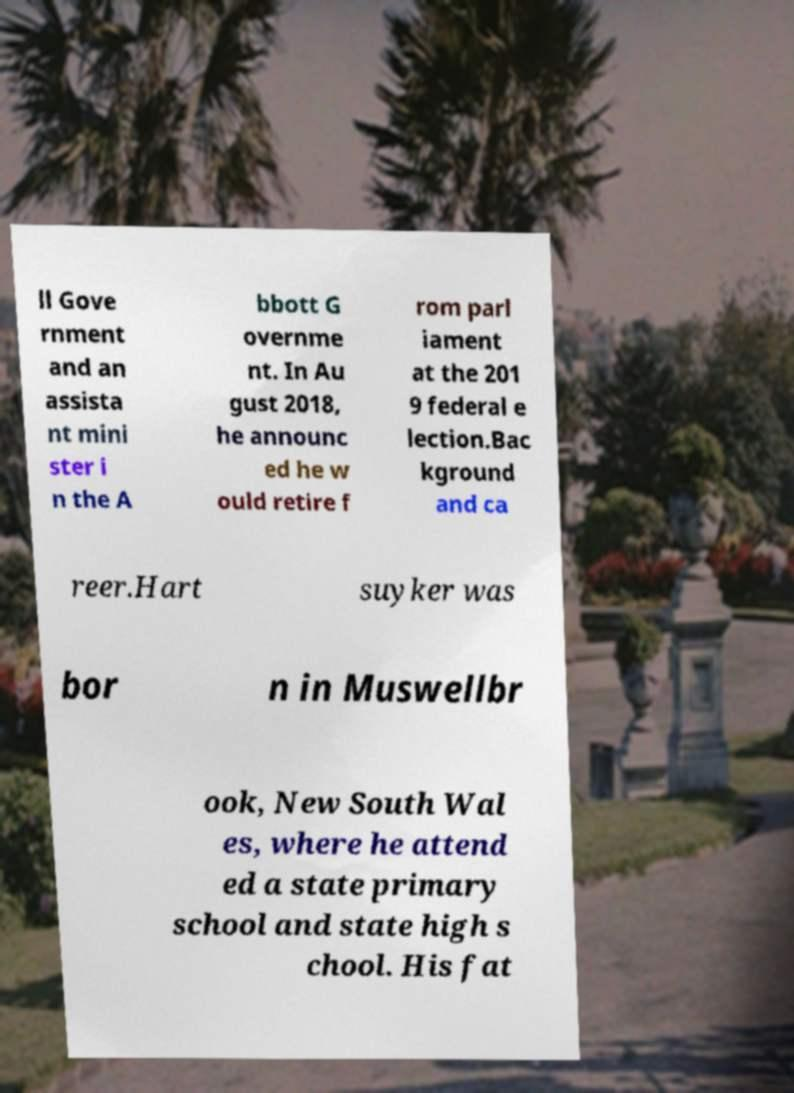I need the written content from this picture converted into text. Can you do that? ll Gove rnment and an assista nt mini ster i n the A bbott G overnme nt. In Au gust 2018, he announc ed he w ould retire f rom parl iament at the 201 9 federal e lection.Bac kground and ca reer.Hart suyker was bor n in Muswellbr ook, New South Wal es, where he attend ed a state primary school and state high s chool. His fat 